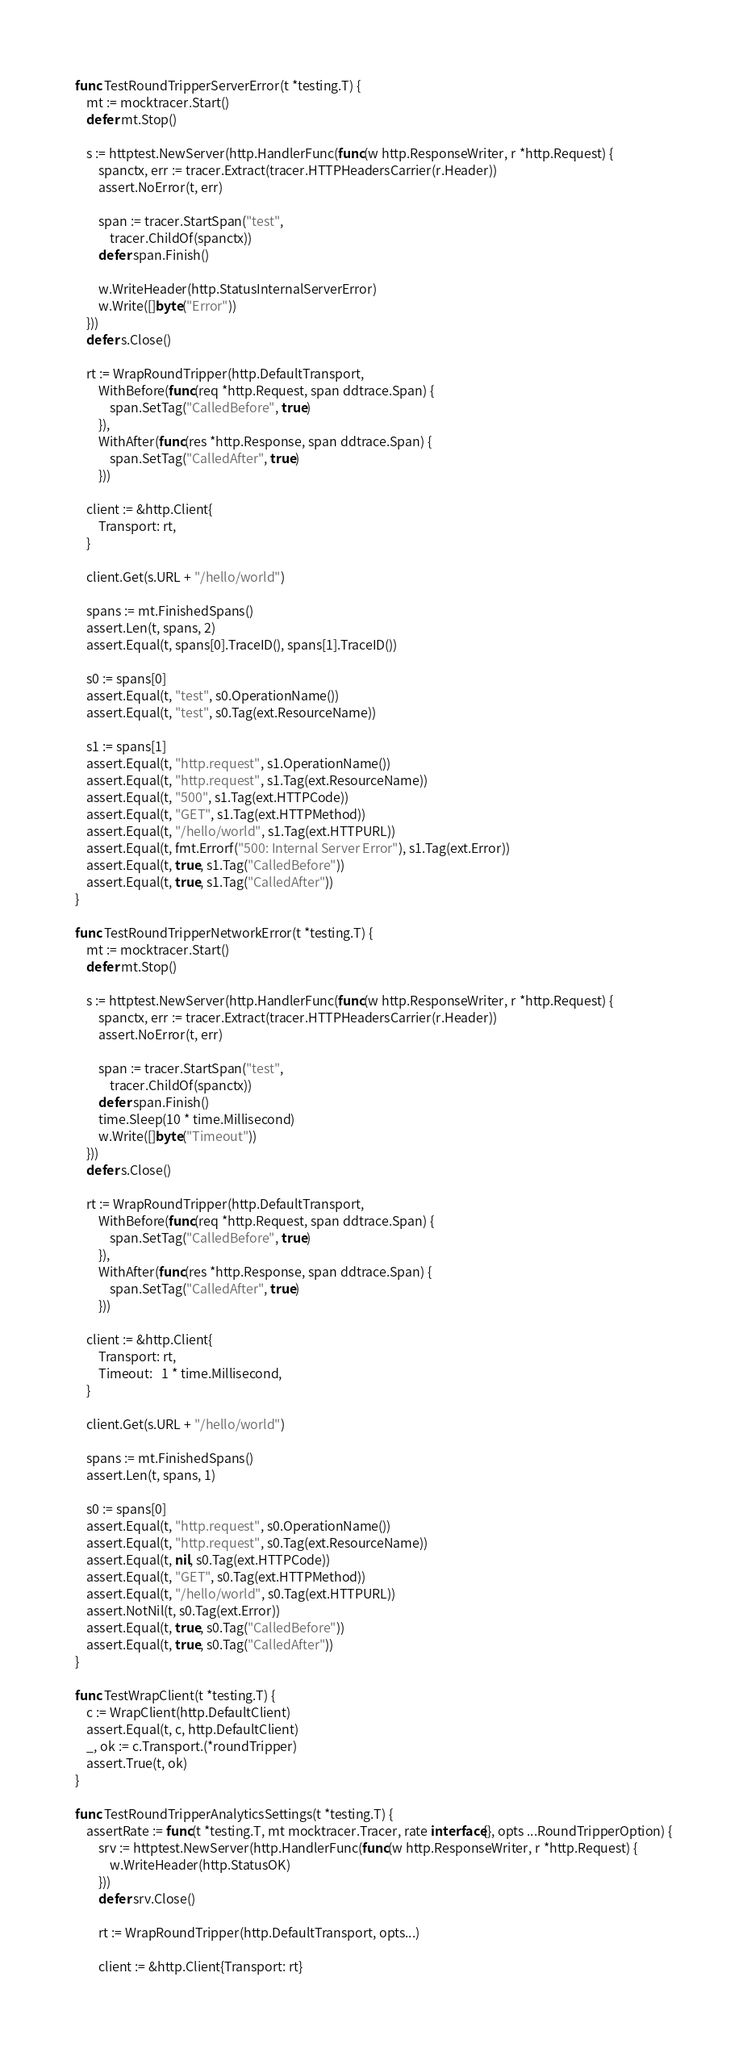Convert code to text. <code><loc_0><loc_0><loc_500><loc_500><_Go_>
func TestRoundTripperServerError(t *testing.T) {
	mt := mocktracer.Start()
	defer mt.Stop()

	s := httptest.NewServer(http.HandlerFunc(func(w http.ResponseWriter, r *http.Request) {
		spanctx, err := tracer.Extract(tracer.HTTPHeadersCarrier(r.Header))
		assert.NoError(t, err)

		span := tracer.StartSpan("test",
			tracer.ChildOf(spanctx))
		defer span.Finish()

		w.WriteHeader(http.StatusInternalServerError)
		w.Write([]byte("Error"))
	}))
	defer s.Close()

	rt := WrapRoundTripper(http.DefaultTransport,
		WithBefore(func(req *http.Request, span ddtrace.Span) {
			span.SetTag("CalledBefore", true)
		}),
		WithAfter(func(res *http.Response, span ddtrace.Span) {
			span.SetTag("CalledAfter", true)
		}))

	client := &http.Client{
		Transport: rt,
	}

	client.Get(s.URL + "/hello/world")

	spans := mt.FinishedSpans()
	assert.Len(t, spans, 2)
	assert.Equal(t, spans[0].TraceID(), spans[1].TraceID())

	s0 := spans[0]
	assert.Equal(t, "test", s0.OperationName())
	assert.Equal(t, "test", s0.Tag(ext.ResourceName))

	s1 := spans[1]
	assert.Equal(t, "http.request", s1.OperationName())
	assert.Equal(t, "http.request", s1.Tag(ext.ResourceName))
	assert.Equal(t, "500", s1.Tag(ext.HTTPCode))
	assert.Equal(t, "GET", s1.Tag(ext.HTTPMethod))
	assert.Equal(t, "/hello/world", s1.Tag(ext.HTTPURL))
	assert.Equal(t, fmt.Errorf("500: Internal Server Error"), s1.Tag(ext.Error))
	assert.Equal(t, true, s1.Tag("CalledBefore"))
	assert.Equal(t, true, s1.Tag("CalledAfter"))
}

func TestRoundTripperNetworkError(t *testing.T) {
	mt := mocktracer.Start()
	defer mt.Stop()

	s := httptest.NewServer(http.HandlerFunc(func(w http.ResponseWriter, r *http.Request) {
		spanctx, err := tracer.Extract(tracer.HTTPHeadersCarrier(r.Header))
		assert.NoError(t, err)

		span := tracer.StartSpan("test",
			tracer.ChildOf(spanctx))
		defer span.Finish()
		time.Sleep(10 * time.Millisecond)
		w.Write([]byte("Timeout"))
	}))
	defer s.Close()

	rt := WrapRoundTripper(http.DefaultTransport,
		WithBefore(func(req *http.Request, span ddtrace.Span) {
			span.SetTag("CalledBefore", true)
		}),
		WithAfter(func(res *http.Response, span ddtrace.Span) {
			span.SetTag("CalledAfter", true)
		}))

	client := &http.Client{
		Transport: rt,
		Timeout:   1 * time.Millisecond,
	}

	client.Get(s.URL + "/hello/world")

	spans := mt.FinishedSpans()
	assert.Len(t, spans, 1)

	s0 := spans[0]
	assert.Equal(t, "http.request", s0.OperationName())
	assert.Equal(t, "http.request", s0.Tag(ext.ResourceName))
	assert.Equal(t, nil, s0.Tag(ext.HTTPCode))
	assert.Equal(t, "GET", s0.Tag(ext.HTTPMethod))
	assert.Equal(t, "/hello/world", s0.Tag(ext.HTTPURL))
	assert.NotNil(t, s0.Tag(ext.Error))
	assert.Equal(t, true, s0.Tag("CalledBefore"))
	assert.Equal(t, true, s0.Tag("CalledAfter"))
}

func TestWrapClient(t *testing.T) {
	c := WrapClient(http.DefaultClient)
	assert.Equal(t, c, http.DefaultClient)
	_, ok := c.Transport.(*roundTripper)
	assert.True(t, ok)
}

func TestRoundTripperAnalyticsSettings(t *testing.T) {
	assertRate := func(t *testing.T, mt mocktracer.Tracer, rate interface{}, opts ...RoundTripperOption) {
		srv := httptest.NewServer(http.HandlerFunc(func(w http.ResponseWriter, r *http.Request) {
			w.WriteHeader(http.StatusOK)
		}))
		defer srv.Close()

		rt := WrapRoundTripper(http.DefaultTransport, opts...)

		client := &http.Client{Transport: rt}</code> 